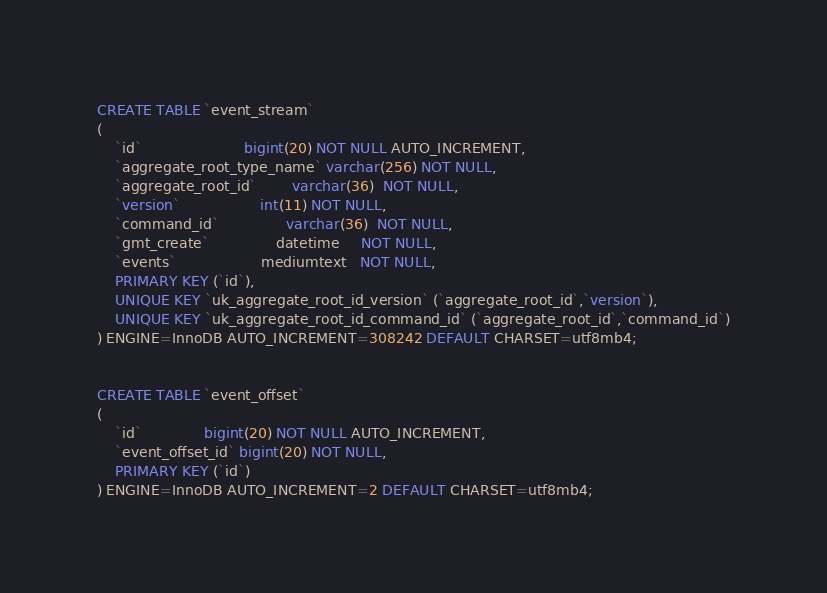Convert code to text. <code><loc_0><loc_0><loc_500><loc_500><_SQL_>CREATE TABLE `event_stream`
(
    `id`                       bigint(20) NOT NULL AUTO_INCREMENT,
    `aggregate_root_type_name` varchar(256) NOT NULL,
    `aggregate_root_id`        varchar(36)  NOT NULL,
    `version`                  int(11) NOT NULL,
    `command_id`               varchar(36)  NOT NULL,
    `gmt_create`               datetime     NOT NULL,
    `events`                   mediumtext   NOT NULL,
    PRIMARY KEY (`id`),
    UNIQUE KEY `uk_aggregate_root_id_version` (`aggregate_root_id`,`version`),
    UNIQUE KEY `uk_aggregate_root_id_command_id` (`aggregate_root_id`,`command_id`)
) ENGINE=InnoDB AUTO_INCREMENT=308242 DEFAULT CHARSET=utf8mb4;


CREATE TABLE `event_offset`
(
    `id`              bigint(20) NOT NULL AUTO_INCREMENT,
    `event_offset_id` bigint(20) NOT NULL,
    PRIMARY KEY (`id`)
) ENGINE=InnoDB AUTO_INCREMENT=2 DEFAULT CHARSET=utf8mb4;</code> 